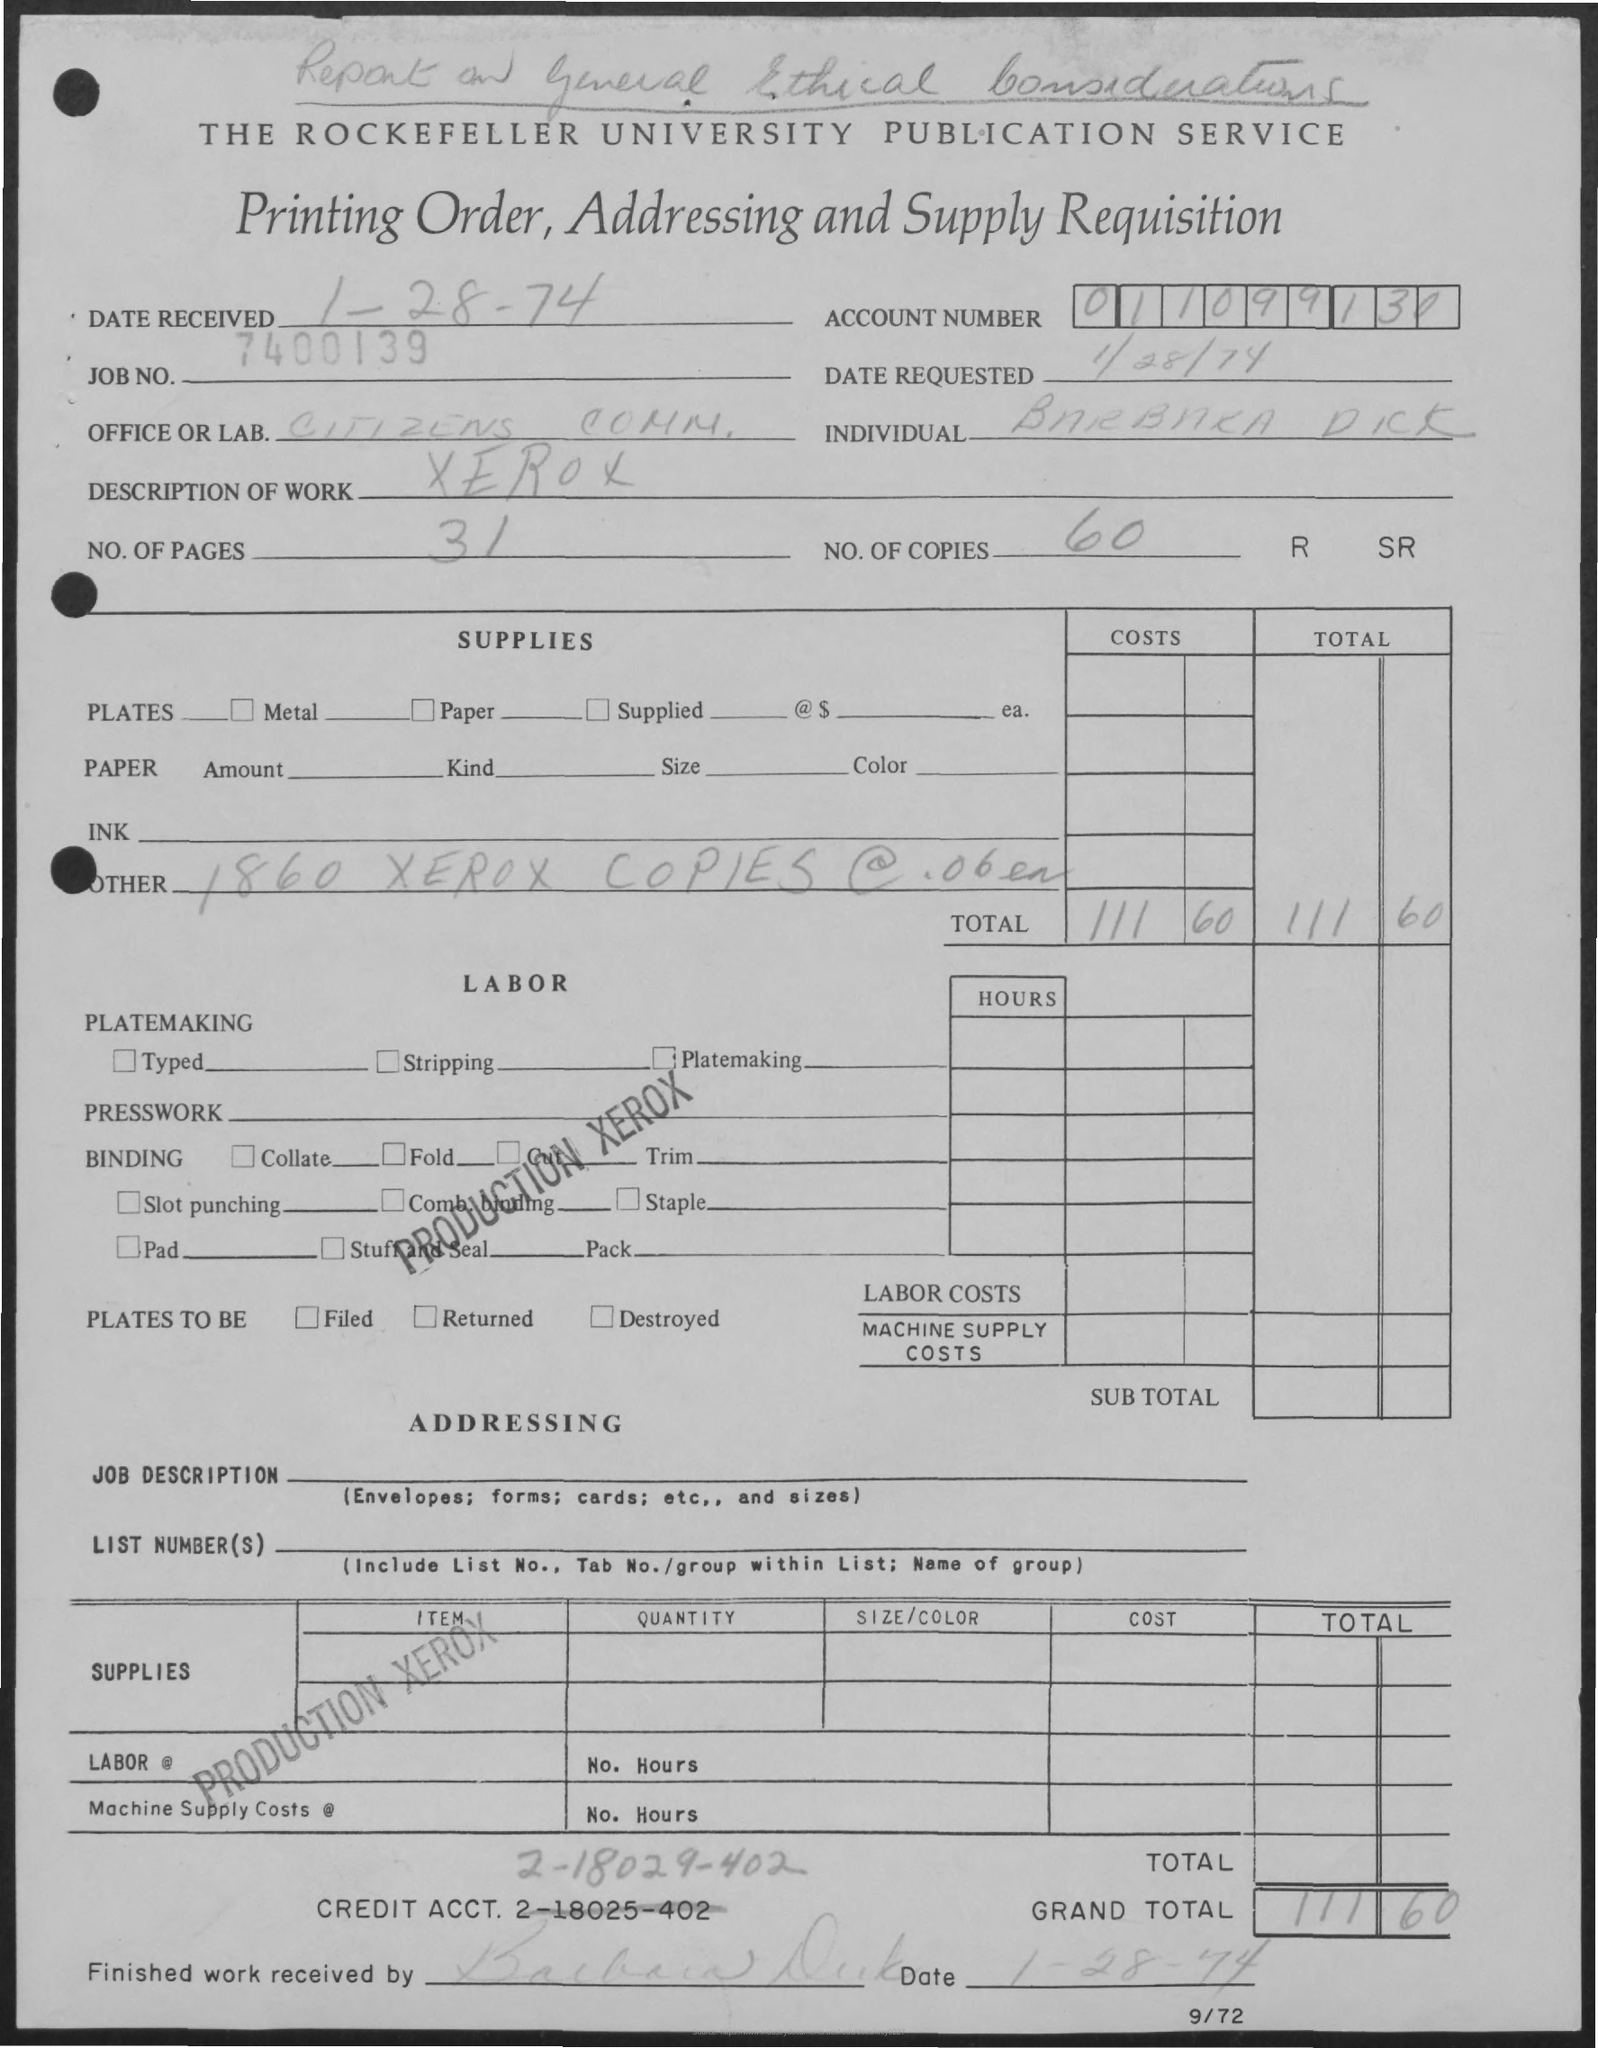Can you tell me the date the order was received? The order was received on January 26, 1974, as noted at the top left corner of the form. 